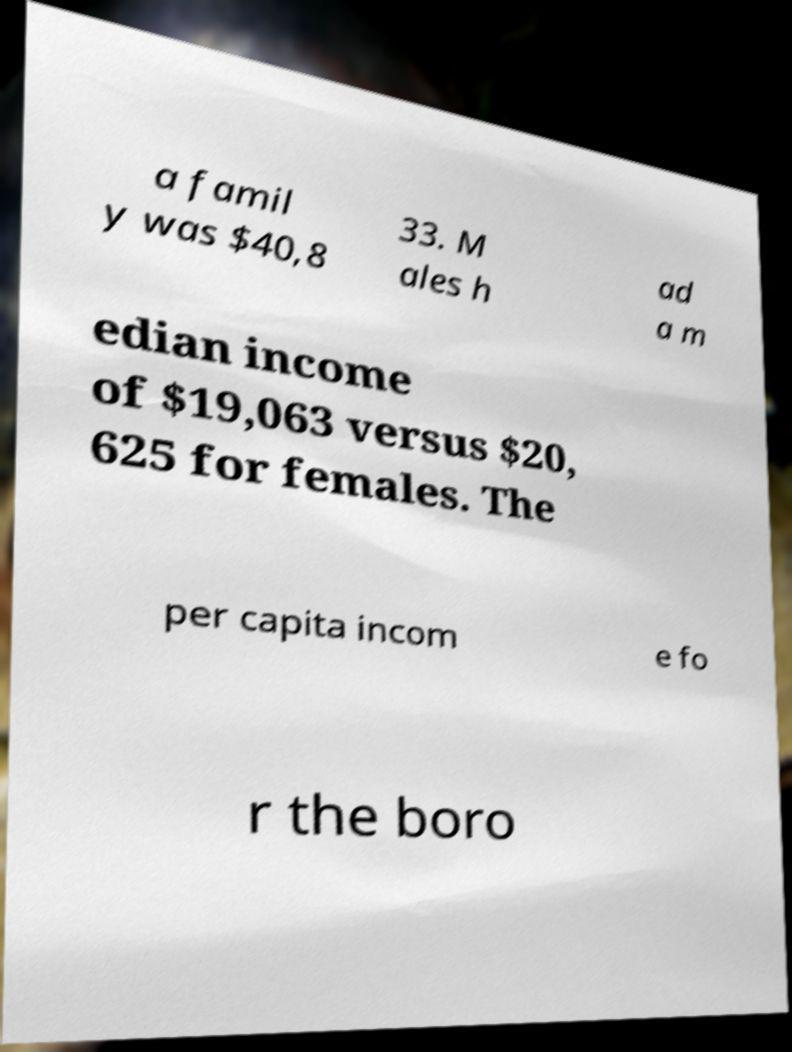Can you accurately transcribe the text from the provided image for me? a famil y was $40,8 33. M ales h ad a m edian income of $19,063 versus $20, 625 for females. The per capita incom e fo r the boro 